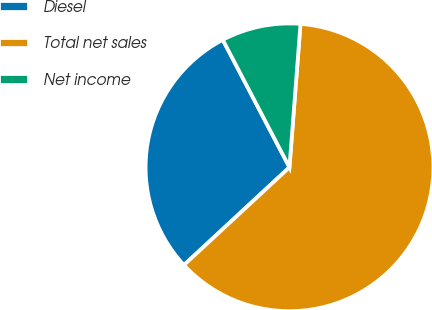Convert chart to OTSL. <chart><loc_0><loc_0><loc_500><loc_500><pie_chart><fcel>Diesel<fcel>Total net sales<fcel>Net income<nl><fcel>29.23%<fcel>61.89%<fcel>8.89%<nl></chart> 